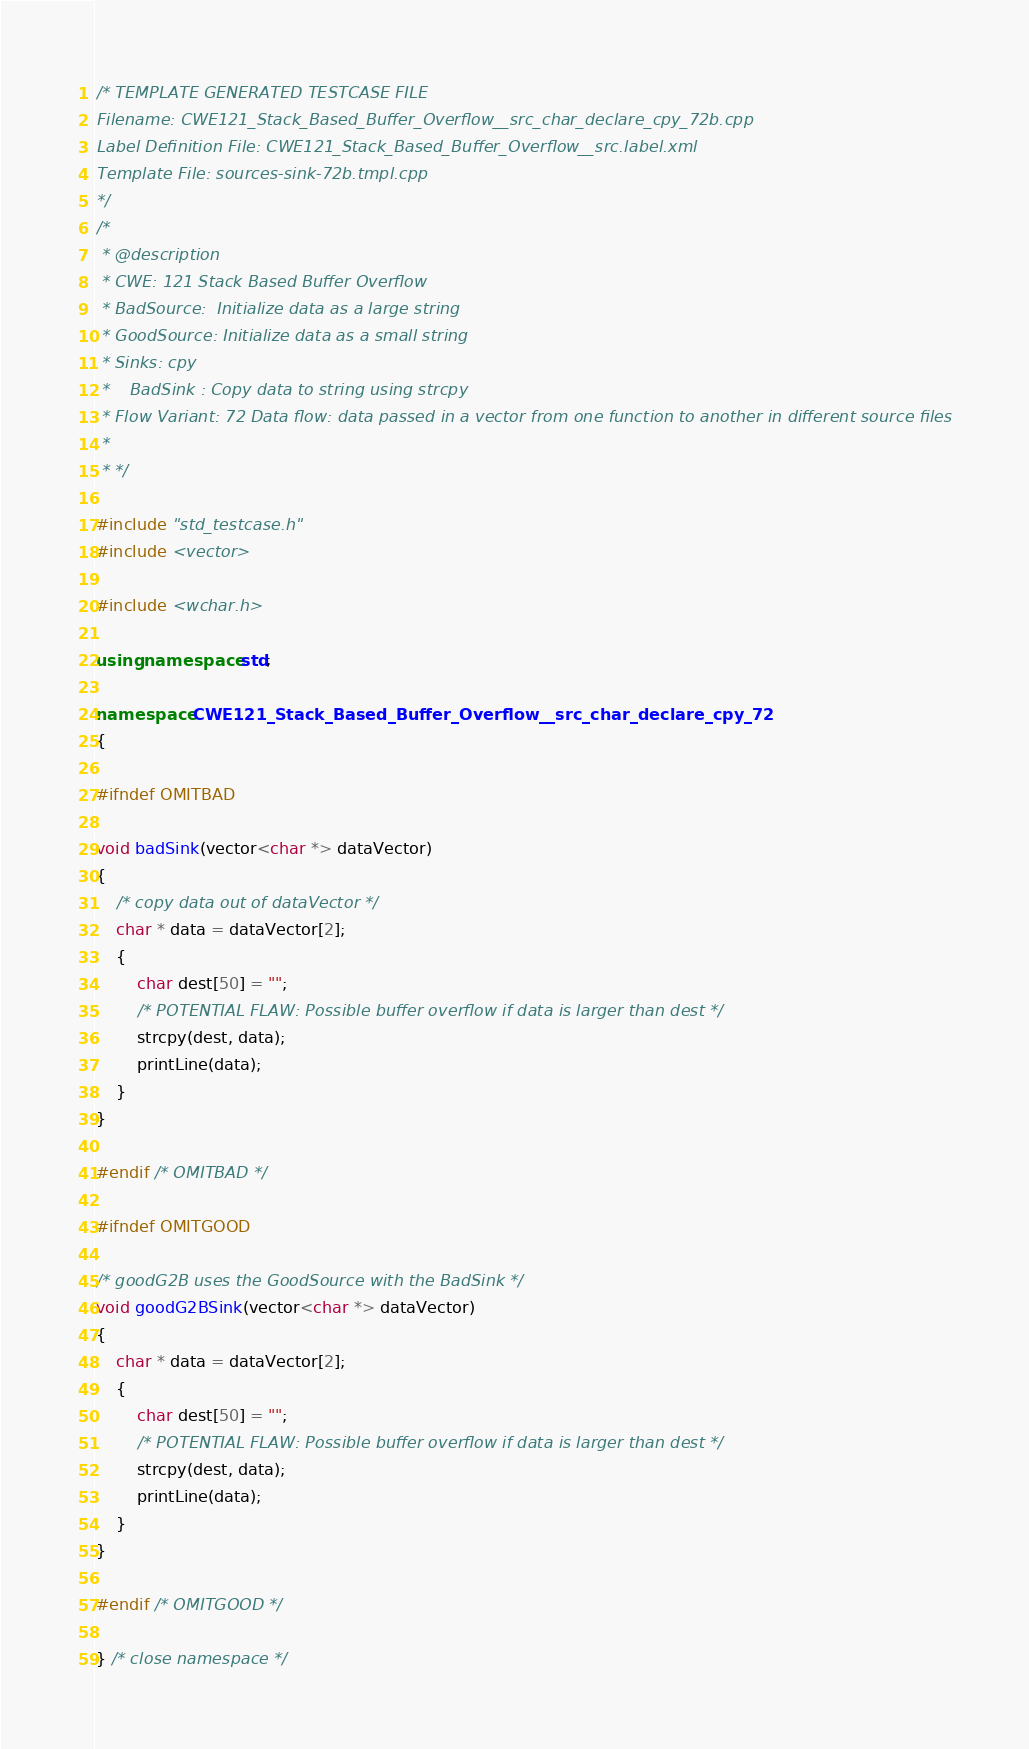<code> <loc_0><loc_0><loc_500><loc_500><_C++_>/* TEMPLATE GENERATED TESTCASE FILE
Filename: CWE121_Stack_Based_Buffer_Overflow__src_char_declare_cpy_72b.cpp
Label Definition File: CWE121_Stack_Based_Buffer_Overflow__src.label.xml
Template File: sources-sink-72b.tmpl.cpp
*/
/*
 * @description
 * CWE: 121 Stack Based Buffer Overflow
 * BadSource:  Initialize data as a large string
 * GoodSource: Initialize data as a small string
 * Sinks: cpy
 *    BadSink : Copy data to string using strcpy
 * Flow Variant: 72 Data flow: data passed in a vector from one function to another in different source files
 *
 * */

#include "std_testcase.h"
#include <vector>

#include <wchar.h>

using namespace std;

namespace CWE121_Stack_Based_Buffer_Overflow__src_char_declare_cpy_72
{

#ifndef OMITBAD

void badSink(vector<char *> dataVector)
{
    /* copy data out of dataVector */
    char * data = dataVector[2];
    {
        char dest[50] = "";
        /* POTENTIAL FLAW: Possible buffer overflow if data is larger than dest */
        strcpy(dest, data);
        printLine(data);
    }
}

#endif /* OMITBAD */

#ifndef OMITGOOD

/* goodG2B uses the GoodSource with the BadSink */
void goodG2BSink(vector<char *> dataVector)
{
    char * data = dataVector[2];
    {
        char dest[50] = "";
        /* POTENTIAL FLAW: Possible buffer overflow if data is larger than dest */
        strcpy(dest, data);
        printLine(data);
    }
}

#endif /* OMITGOOD */

} /* close namespace */
</code> 